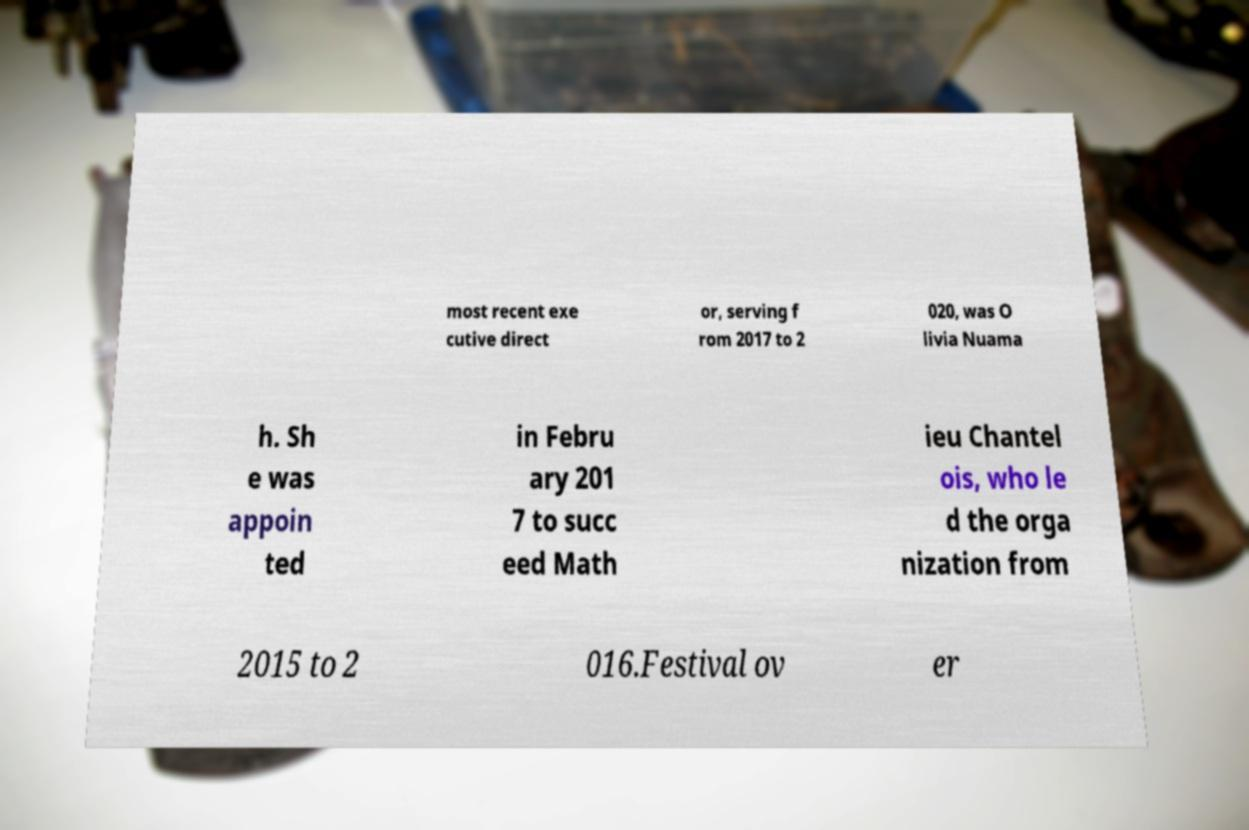I need the written content from this picture converted into text. Can you do that? most recent exe cutive direct or, serving f rom 2017 to 2 020, was O livia Nuama h. Sh e was appoin ted in Febru ary 201 7 to succ eed Math ieu Chantel ois, who le d the orga nization from 2015 to 2 016.Festival ov er 